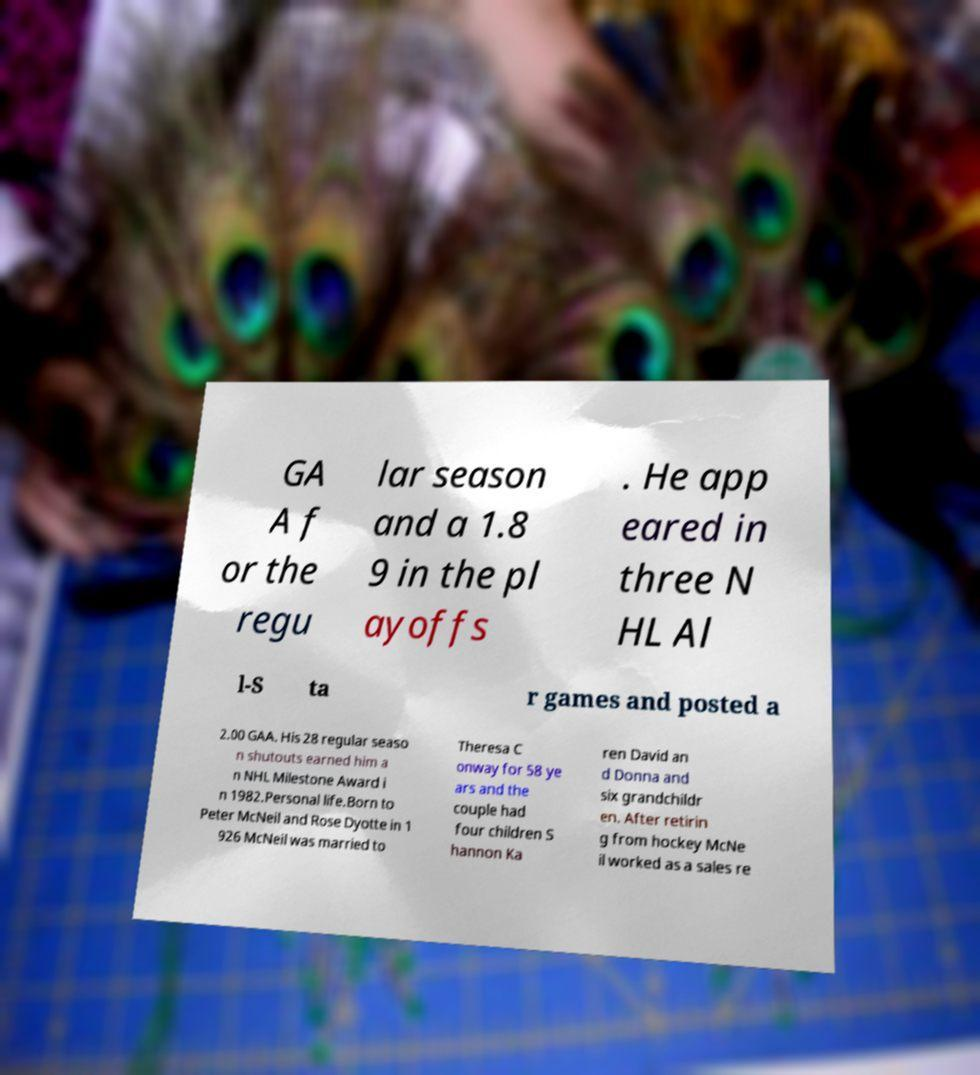Please identify and transcribe the text found in this image. GA A f or the regu lar season and a 1.8 9 in the pl ayoffs . He app eared in three N HL Al l-S ta r games and posted a 2.00 GAA. His 28 regular seaso n shutouts earned him a n NHL Milestone Award i n 1982.Personal life.Born to Peter McNeil and Rose Dyotte in 1 926 McNeil was married to Theresa C onway for 58 ye ars and the couple had four children S hannon Ka ren David an d Donna and six grandchildr en. After retirin g from hockey McNe il worked as a sales re 